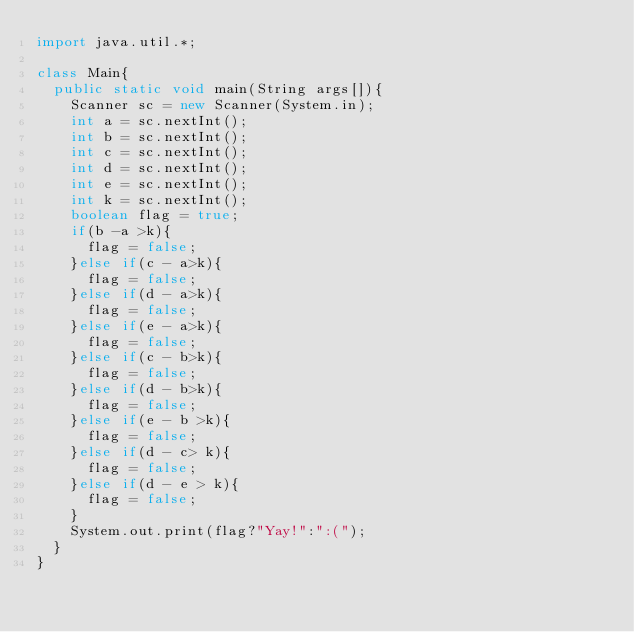<code> <loc_0><loc_0><loc_500><loc_500><_Java_>import java.util.*;

class Main{
	public static void main(String args[]){
		Scanner sc = new Scanner(System.in);
		int a = sc.nextInt();
		int b = sc.nextInt();
		int c = sc.nextInt();
		int d = sc.nextInt();
		int e = sc.nextInt();
		int k = sc.nextInt();
		boolean flag = true;
		if(b -a >k){
			flag = false;
		}else if(c - a>k){
			flag = false;
		}else if(d - a>k){
			flag = false;
		}else if(e - a>k){
			flag = false;
		}else if(c - b>k){
			flag = false;
		}else if(d - b>k){
			flag = false;
		}else if(e - b >k){
			flag = false;
		}else if(d - c> k){
			flag = false;
		}else if(d - e > k){
			flag = false;
		}
		System.out.print(flag?"Yay!":":(");
	}
}
</code> 